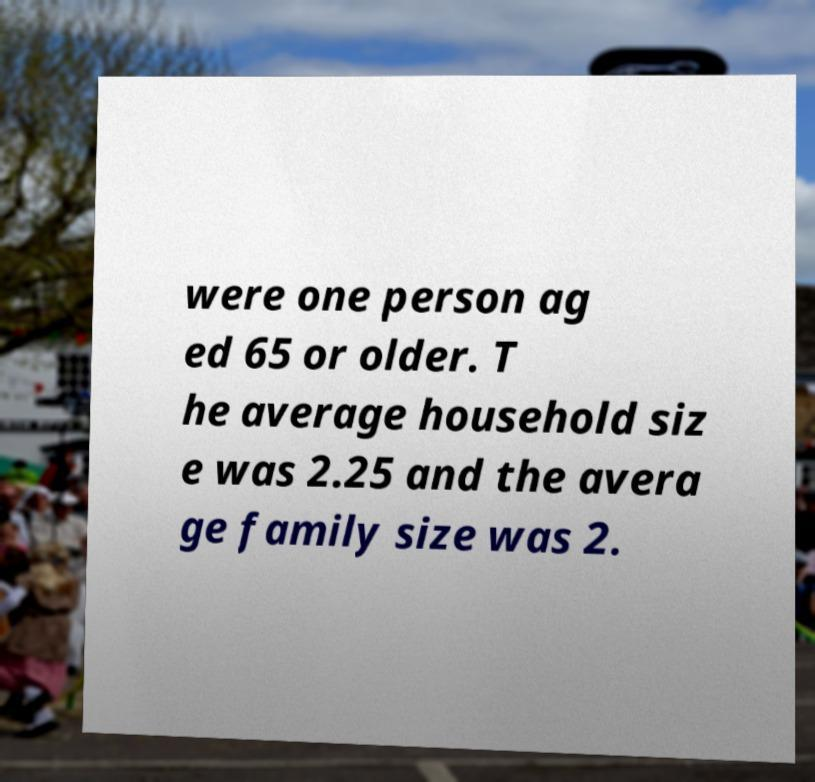I need the written content from this picture converted into text. Can you do that? were one person ag ed 65 or older. T he average household siz e was 2.25 and the avera ge family size was 2. 